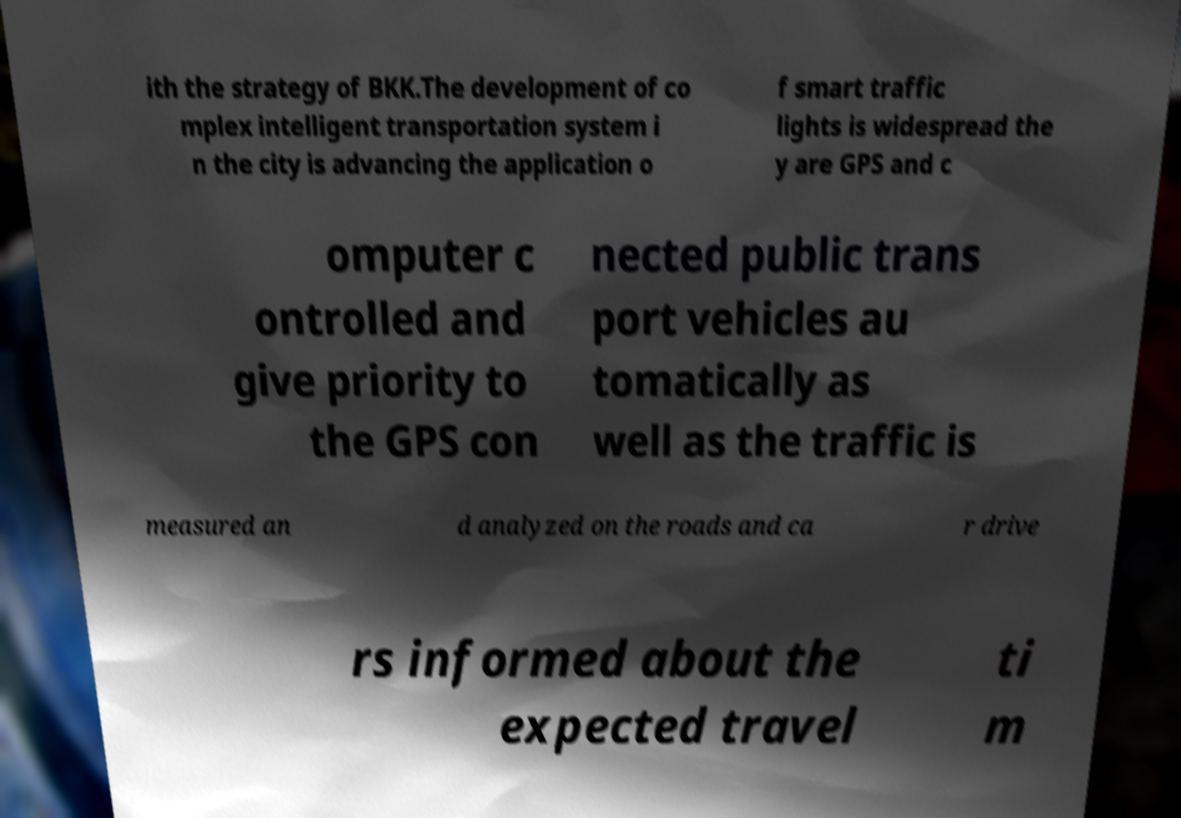Can you read and provide the text displayed in the image?This photo seems to have some interesting text. Can you extract and type it out for me? ith the strategy of BKK.The development of co mplex intelligent transportation system i n the city is advancing the application o f smart traffic lights is widespread the y are GPS and c omputer c ontrolled and give priority to the GPS con nected public trans port vehicles au tomatically as well as the traffic is measured an d analyzed on the roads and ca r drive rs informed about the expected travel ti m 